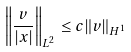Convert formula to latex. <formula><loc_0><loc_0><loc_500><loc_500>\left \| \frac { v } { | x | } \right \| _ { L ^ { 2 } } \leq c \| v \| _ { H ^ { 1 } }</formula> 